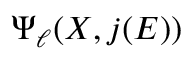Convert formula to latex. <formula><loc_0><loc_0><loc_500><loc_500>\Psi _ { \ell } ( X , j ( E ) )</formula> 